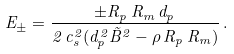Convert formula to latex. <formula><loc_0><loc_0><loc_500><loc_500>E _ { \pm } = \frac { \pm R _ { p } \, R _ { m } \, d _ { p } } { 2 \, c _ { s } ^ { 2 } ( d _ { p } ^ { 2 } \tilde { B } ^ { 2 } - \rho \, R _ { p } \, R _ { m } ) } \, .</formula> 